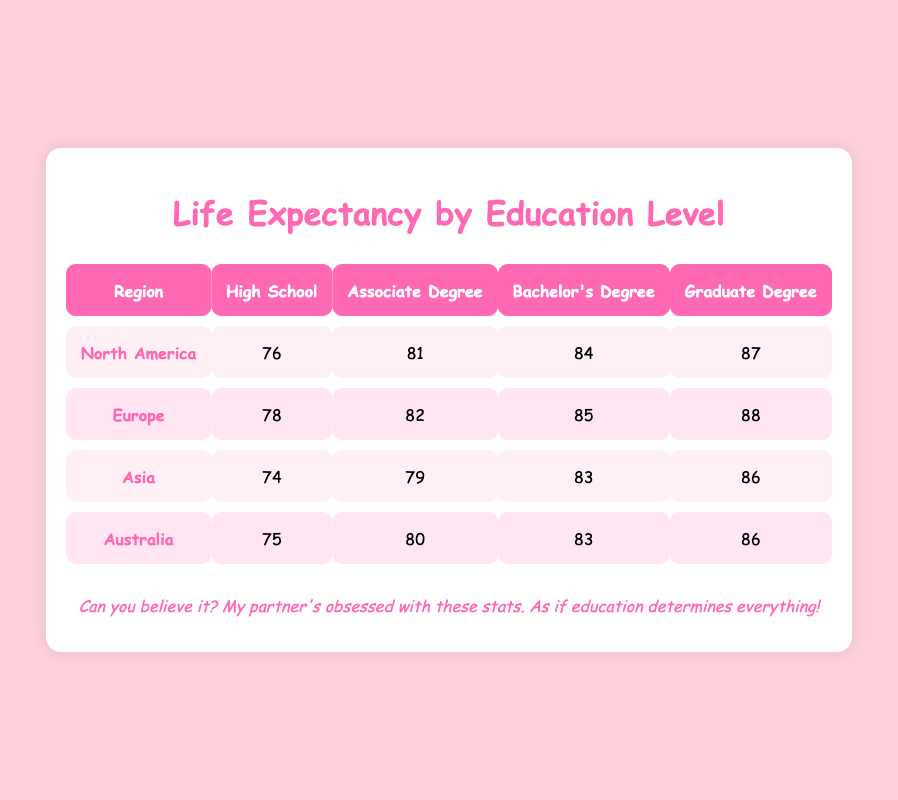What is the life expectancy for someone with a Graduate Degree in North America? The table shows that in North America, the life expectancy for someone with a Graduate Degree is listed as 87 years.
Answer: 87 How much higher is the life expectancy for someone with a Bachelor's Degree compared to someone with a High School education in Europe? In Europe, the life expectancy for a Bachelor's Degree is 85 years, and for High School, it is 78 years. The difference is 85 - 78 = 7 years.
Answer: 7 years Is the life expectancy for Asia's Associate Degree higher than that for High School in the same region? In Asia, the life expectancy for someone with an Associate Degree is 79 years, while for High School it is 74 years. Since 79 is greater than 74, the statement is true.
Answer: Yes What is the average life expectancy for people with a Graduate Degree across all regions? The life expectancy for people with a Graduate Degree in each region is: North America (87), Europe (88), Asia (86), and Australia (86). The average is calculated as (87 + 88 + 86 + 86) / 4 = 87.75, which can be rounded to 88.
Answer: 88 How does the life expectancy for someone with an Associate Degree in Australia compare to that in North America? In Australia, the life expectancy for an Associate Degree is 80 years, while in North America, it is 81 years. Comparing the two, 81 is greater than 80, indicating life expectancy is higher in North America.
Answer: North America is higher 